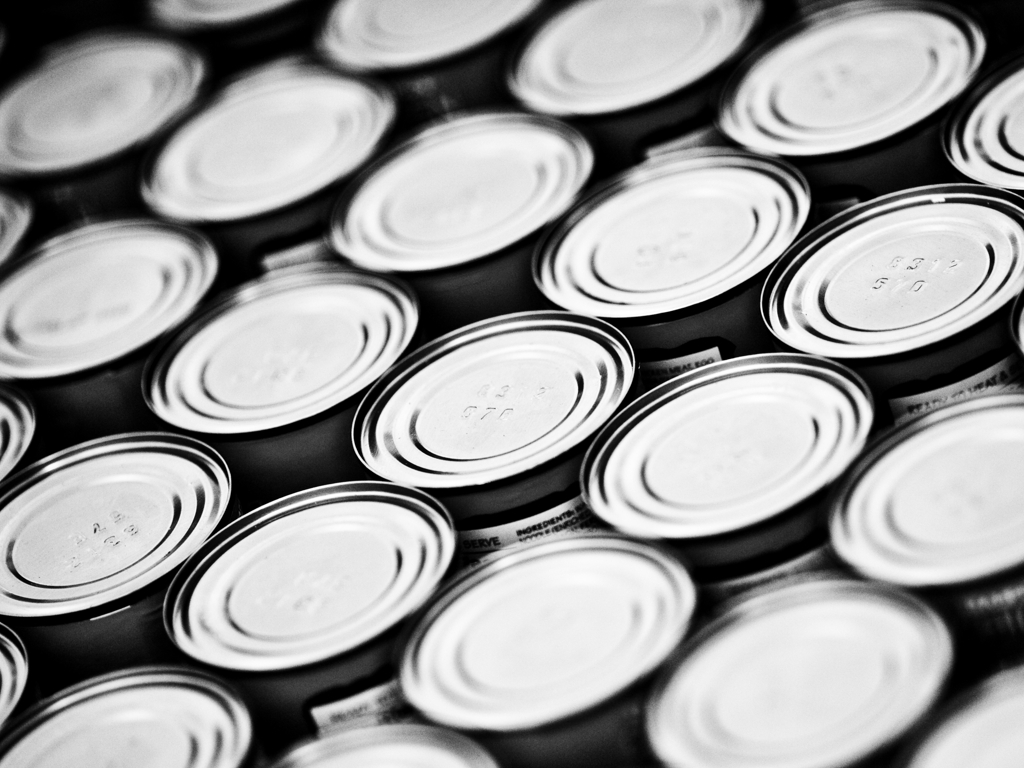Is there any significance to the pattern formed by the arrangement of the lids? The pattern created by the arrangement of the lids in the image lends a sense of order and uniformity. It can be aesthetically pleasing as it draws the eye into the rhythmic repetition and can also signal organization and efficiency in the storage or manufacturing process. Could the image be symbolic in any way? Symbols are often in the eye of the beholder. The repetitive nature of the lids might suggest themes of mass production, consumerism, or the abundance of packaged goods in modern society. It might also evoke feelings of consistency, reliability, or the complexity hidden within seemingly simple objects. 